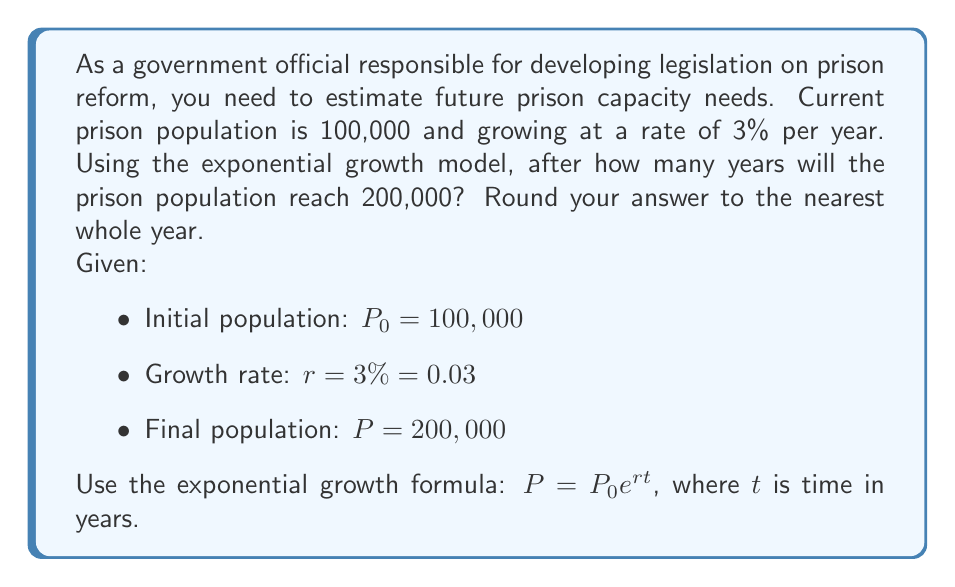Teach me how to tackle this problem. To solve this problem, we'll use the exponential growth formula and properties of logarithms:

1) Start with the exponential growth formula:
   $P = P_0 e^{rt}$

2) Substitute the known values:
   $200,000 = 100,000 e^{0.03t}$

3) Divide both sides by 100,000:
   $2 = e^{0.03t}$

4) Take the natural logarithm of both sides:
   $\ln(2) = \ln(e^{0.03t})$

5) Use the logarithm property $\ln(e^x) = x$:
   $\ln(2) = 0.03t$

6) Solve for $t$:
   $t = \frac{\ln(2)}{0.03}$

7) Calculate the result:
   $t = \frac{0.693147...}{0.03} \approx 23.10490...$

8) Round to the nearest whole year:
   $t \approx 23$ years
Answer: 23 years 